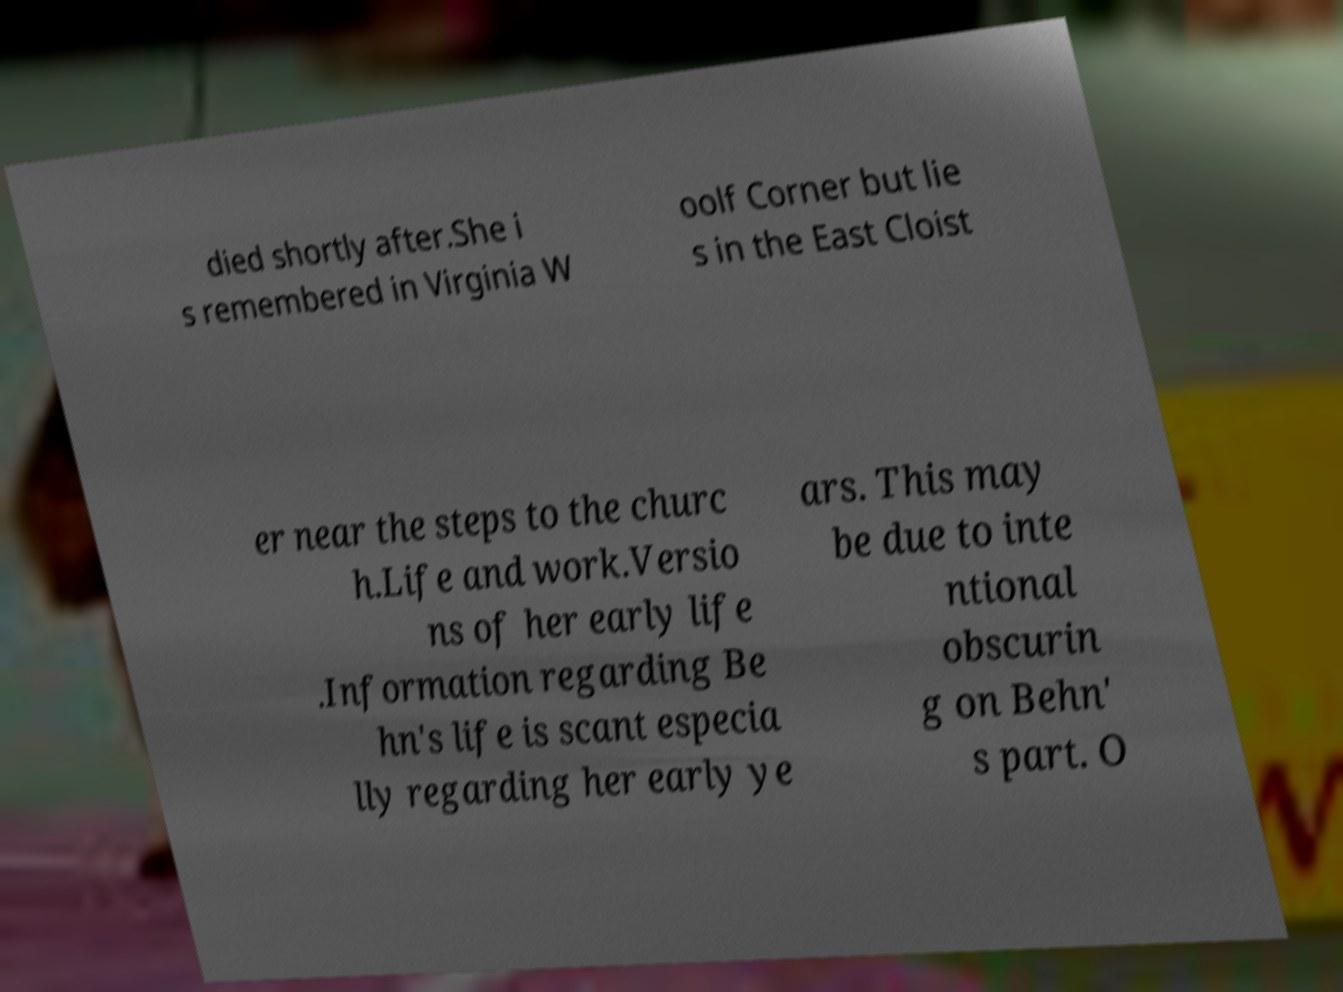Could you extract and type out the text from this image? died shortly after.She i s remembered in Virginia W oolf Corner but lie s in the East Cloist er near the steps to the churc h.Life and work.Versio ns of her early life .Information regarding Be hn's life is scant especia lly regarding her early ye ars. This may be due to inte ntional obscurin g on Behn' s part. O 